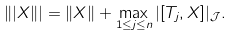Convert formula to latex. <formula><loc_0><loc_0><loc_500><loc_500>\| | X \| | = \| X \| + \max _ { 1 \leq j \leq n } | [ T _ { j } , X ] | _ { \mathcal { J } } .</formula> 